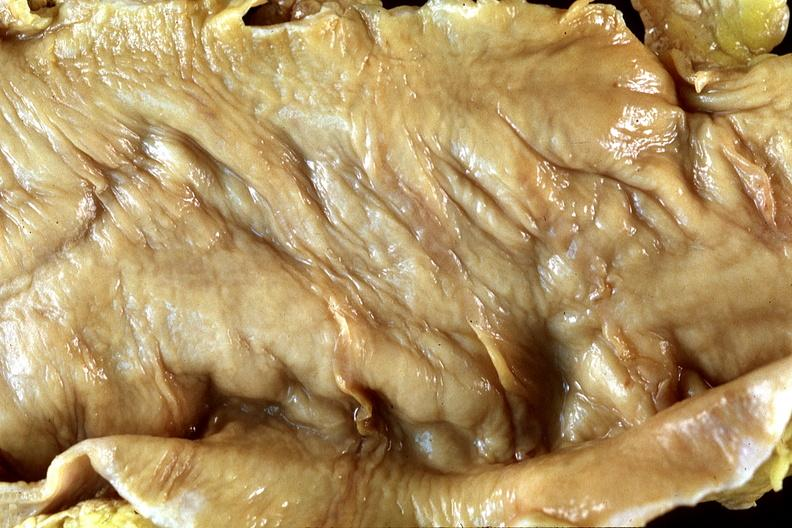what does this image show?
Answer the question using a single word or phrase. Normal colon 